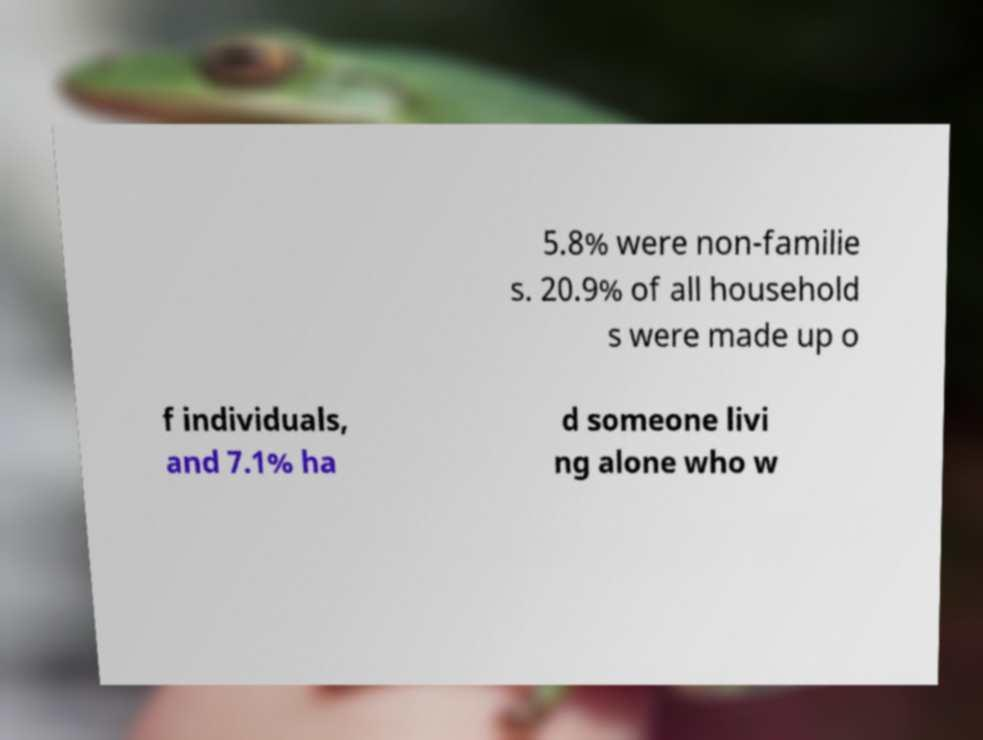Please read and relay the text visible in this image. What does it say? 5.8% were non-familie s. 20.9% of all household s were made up o f individuals, and 7.1% ha d someone livi ng alone who w 